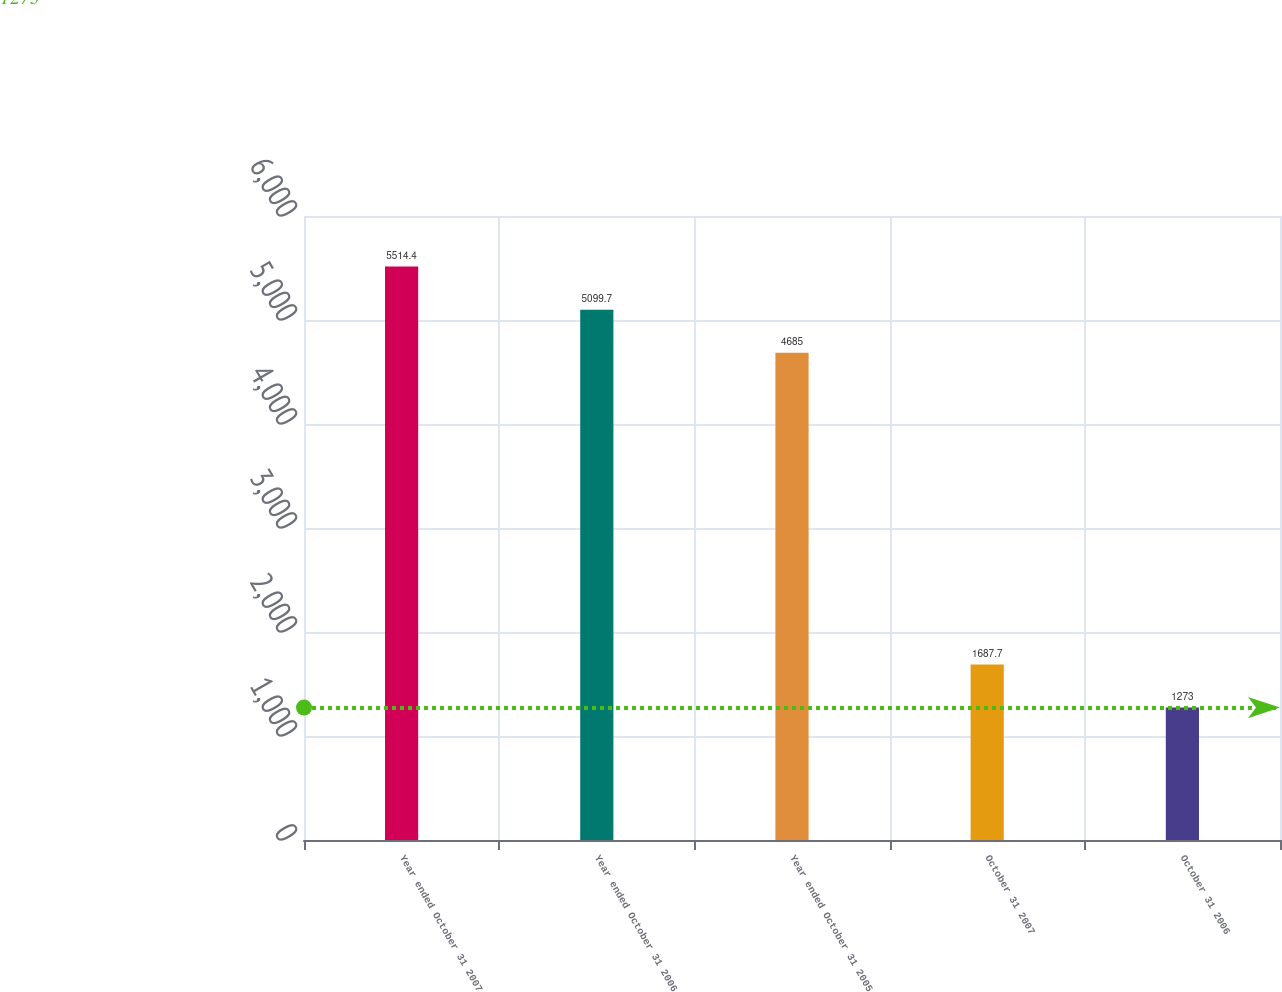Convert chart. <chart><loc_0><loc_0><loc_500><loc_500><bar_chart><fcel>Year ended October 31 2007<fcel>Year ended October 31 2006<fcel>Year ended October 31 2005<fcel>October 31 2007<fcel>October 31 2006<nl><fcel>5514.4<fcel>5099.7<fcel>4685<fcel>1687.7<fcel>1273<nl></chart> 